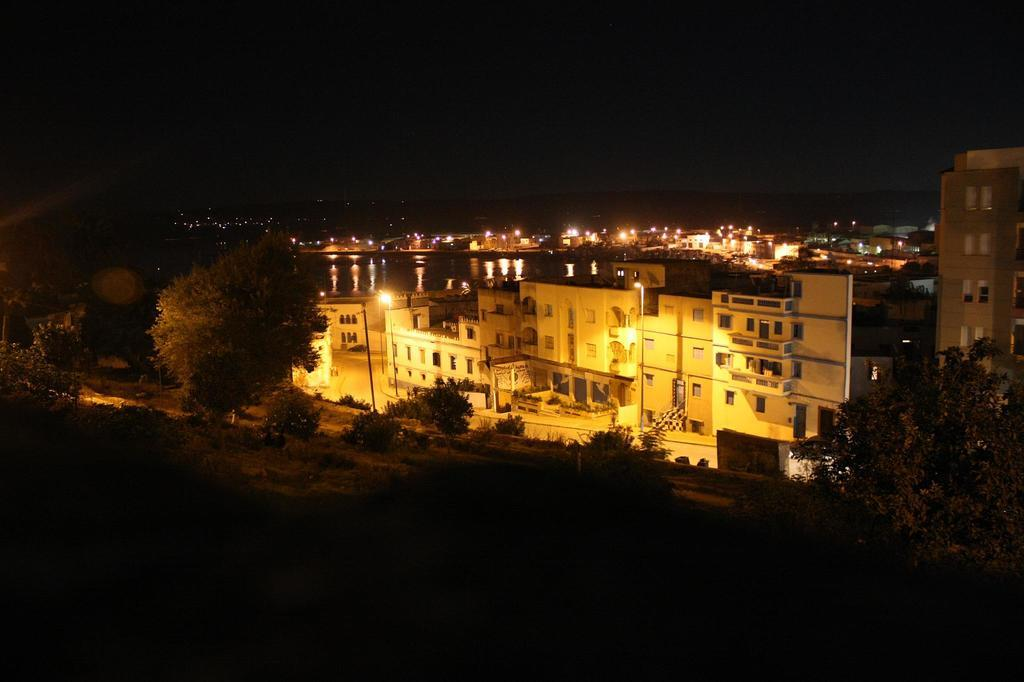What type of structures can be seen in the image? There are buildings in the image. What can be seen illuminating the area in the image? There is lighting visible in the image. What type of vegetation is present in the image? There are trees and plants in the image. What type of lighting fixtures can be seen in the image? There are pole lights in the image. What type of jewel is the owl wearing around its neck in the image? There is no owl or jewel present in the image. 